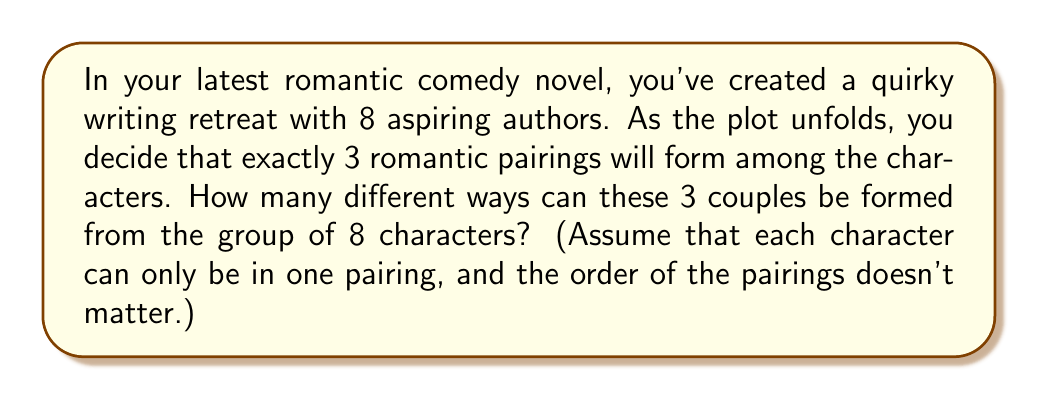Can you answer this question? Let's approach this step-by-step with a dash of romantic flair:

1) First, we need to choose 6 people out of 8 to be in the three couples. This can be done in $\binom{8}{6}$ ways.

2) Now, we need to pair these 6 people into 3 couples. This is equivalent to dividing 6 people into 3 groups of 2, which is a partition problem.

3) The number of ways to partition 6 people into 3 pairs is given by the formula:

   $$\frac{6!}{(2!)^3 \cdot 3!}$$

   Where 6! accounts for all permutations of 6 people, $(2!)^3$ accounts for the internal order of each pair (which doesn't matter), and 3! accounts for the order of the pairs (which also doesn't matter).

4) Putting it all together, the total number of ways to form 3 couples from 8 people is:

   $$\binom{8}{6} \cdot \frac{6!}{(2!)^3 \cdot 3!}$$

5) Let's calculate:
   
   $\binom{8}{6} = \frac{8!}{6!(8-6)!} = \frac{8!}{6!2!} = 28$
   
   $\frac{6!}{(2!)^3 \cdot 3!} = \frac{720}{8 \cdot 6} = 15$

6) Therefore, the final answer is:

   $28 \cdot 15 = 420$

Thus, there are 420 different ways to form 3 couples from a group of 8 characters, providing plenty of plot twists for your rom-com!
Answer: 420 ways 